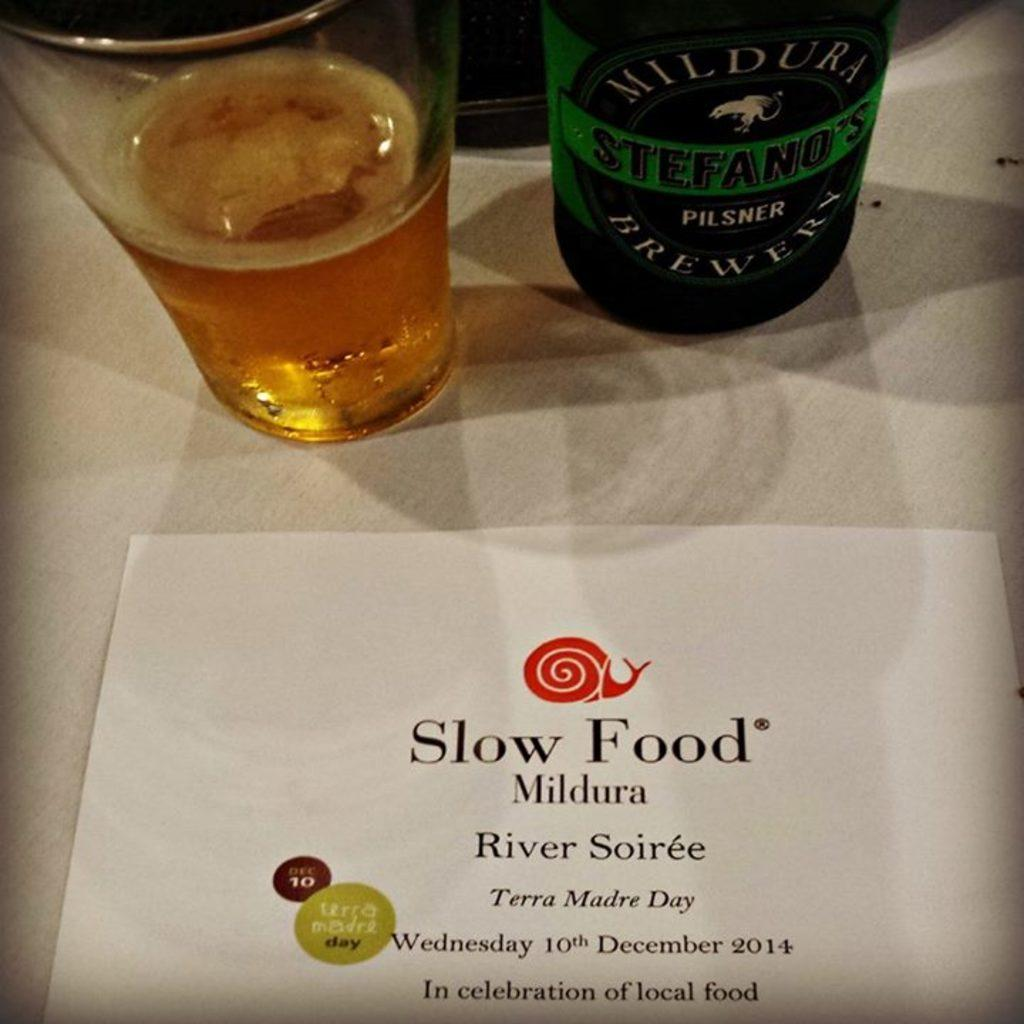<image>
Relay a brief, clear account of the picture shown. a sign for Slow Food is in front of a glass and bottle of beer 